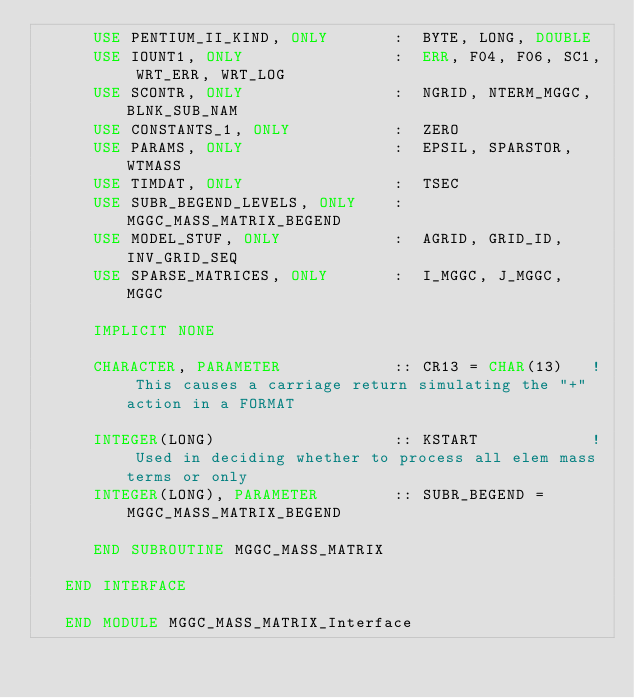Convert code to text. <code><loc_0><loc_0><loc_500><loc_500><_FORTRAN_>      USE PENTIUM_II_KIND, ONLY       :  BYTE, LONG, DOUBLE
      USE IOUNT1, ONLY                :  ERR, F04, F06, SC1, WRT_ERR, WRT_LOG
      USE SCONTR, ONLY                :  NGRID, NTERM_MGGC, BLNK_SUB_NAM
      USE CONSTANTS_1, ONLY           :  ZERO
      USE PARAMS, ONLY                :  EPSIL, SPARSTOR, WTMASS
      USE TIMDAT, ONLY                :  TSEC
      USE SUBR_BEGEND_LEVELS, ONLY    :  MGGC_MASS_MATRIX_BEGEND
      USE MODEL_STUF, ONLY            :  AGRID, GRID_ID, INV_GRID_SEQ
      USE SPARSE_MATRICES, ONLY       :  I_MGGC, J_MGGC, MGGC
 
      IMPLICIT NONE
  
      CHARACTER, PARAMETER            :: CR13 = CHAR(13)   ! This causes a carriage return simulating the "+" action in a FORMAT

      INTEGER(LONG)                   :: KSTART            ! Used in deciding whether to process all elem mass terms or only
      INTEGER(LONG), PARAMETER        :: SUBR_BEGEND = MGGC_MASS_MATRIX_BEGEND

      END SUBROUTINE MGGC_MASS_MATRIX

   END INTERFACE

   END MODULE MGGC_MASS_MATRIX_Interface

</code> 